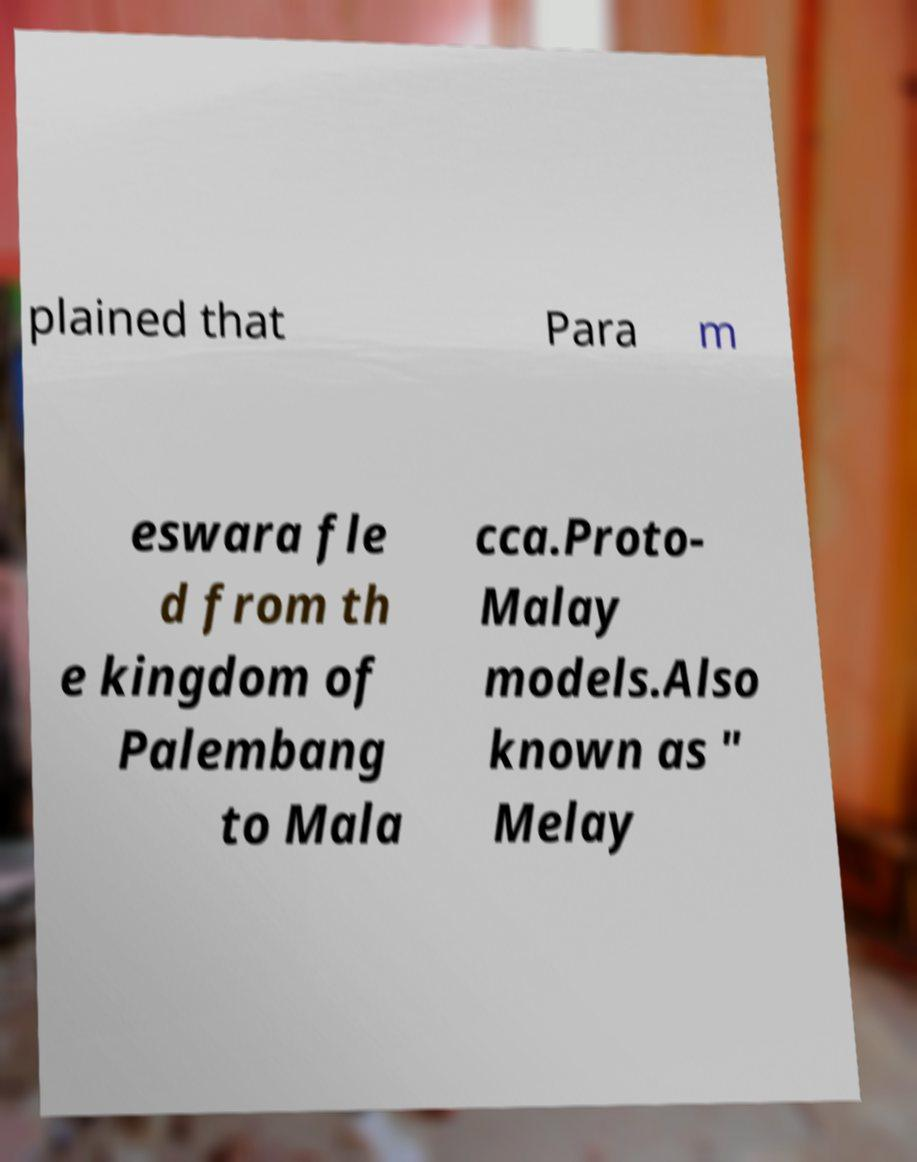Please identify and transcribe the text found in this image. plained that Para m eswara fle d from th e kingdom of Palembang to Mala cca.Proto- Malay models.Also known as " Melay 